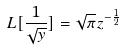Convert formula to latex. <formula><loc_0><loc_0><loc_500><loc_500>L [ \frac { 1 } { \sqrt { y } } ] = \sqrt { \pi } z ^ { - \frac { 1 } { 2 } }</formula> 